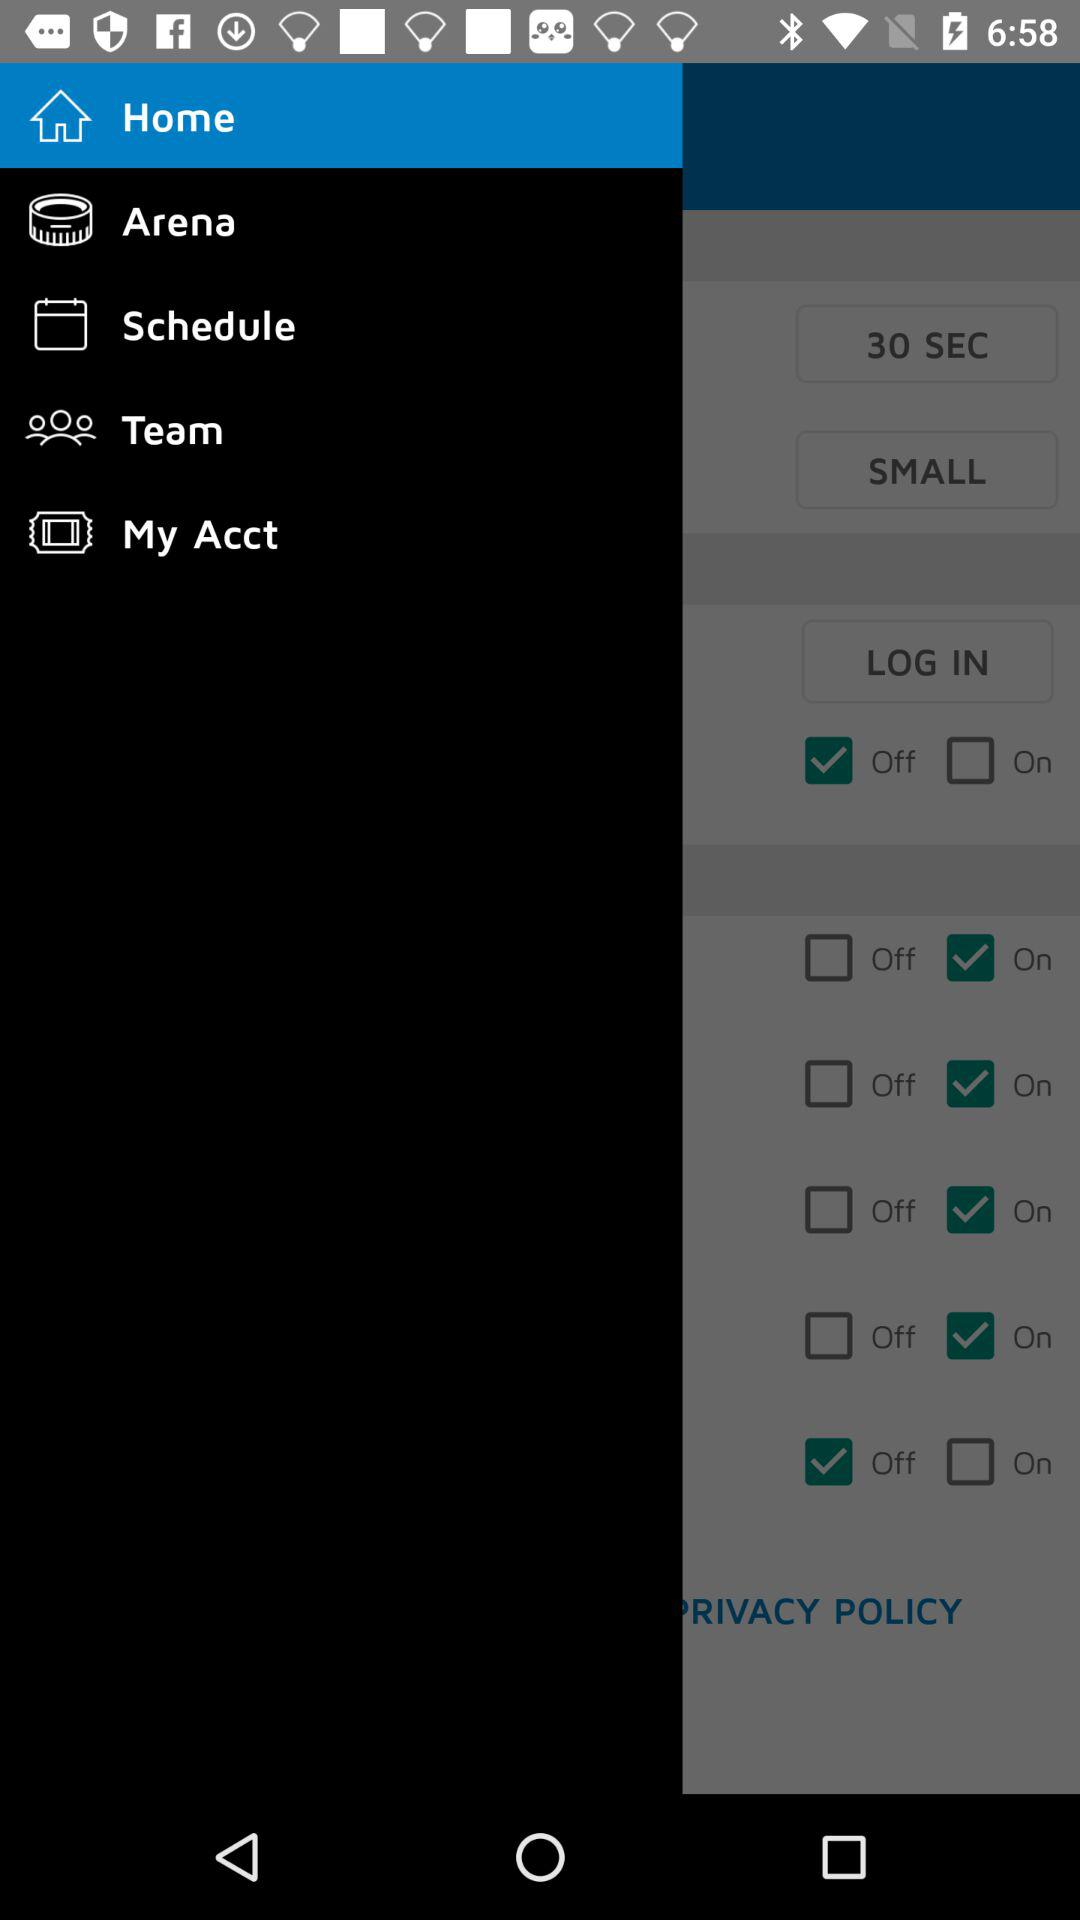What tab has been selected? The selected tab is Home. 